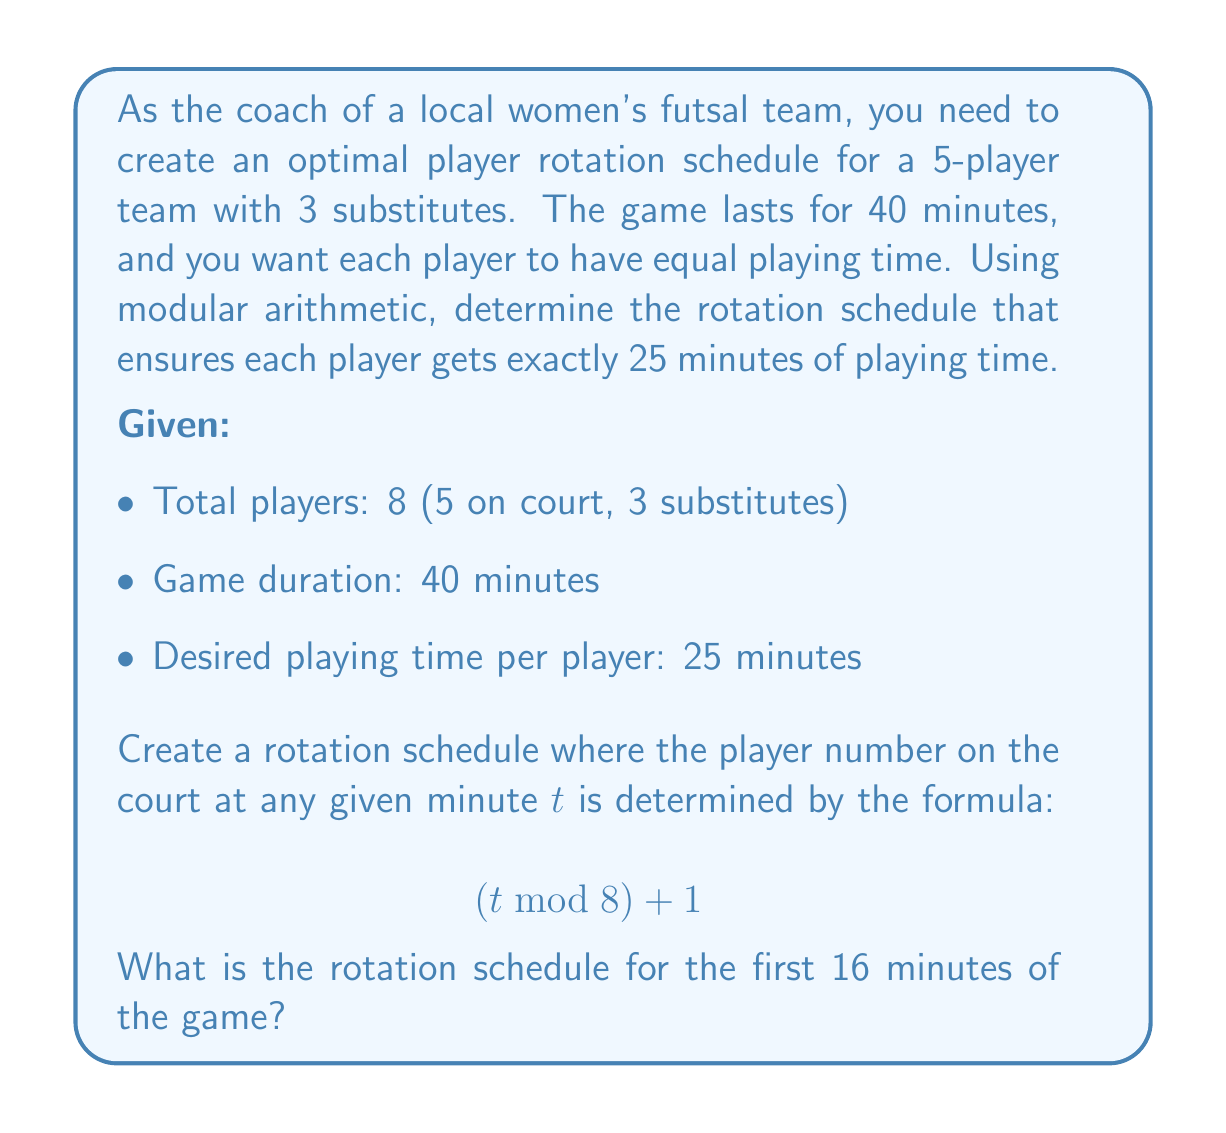Can you solve this math problem? Let's approach this step-by-step:

1) First, we need to understand what the formula means:
   $$(t \bmod 8) + 1$$
   This formula will give us a number between 1 and 8, representing the player number.

2) We'll calculate this for $t = 0$ to $t = 15$ (first 16 minutes):

   For $t = 0$: $(0 \bmod 8) + 1 = 0 + 1 = 1$
   For $t = 1$: $(1 \bmod 8) + 1 = 1 + 1 = 2$
   For $t = 2$: $(2 \bmod 8) + 1 = 2 + 1 = 3$
   For $t = 3$: $(3 \bmod 8) + 1 = 3 + 1 = 4$
   For $t = 4$: $(4 \bmod 8) + 1 = 4 + 1 = 5$
   For $t = 5$: $(5 \bmod 8) + 1 = 5 + 1 = 6$
   For $t = 6$: $(6 \bmod 8) + 1 = 6 + 1 = 7$
   For $t = 7$: $(7 \bmod 8) + 1 = 7 + 1 = 8$
   For $t = 8$: $(8 \bmod 8) + 1 = 0 + 1 = 1$
   For $t = 9$: $(9 \bmod 8) + 1 = 1 + 1 = 2$
   ...and so on.

3) This creates a repeating pattern every 8 minutes.

4) We can represent this as a rotation schedule:

   Minute 0: Players 1, 2, 3, 4, 5 on court
   Minute 1: Players 2, 3, 4, 5, 6 on court
   Minute 2: Players 3, 4, 5, 6, 7 on court
   Minute 3: Players 4, 5, 6, 7, 8 on court
   Minute 4: Players 5, 6, 7, 8, 1 on court
   Minute 5: Players 6, 7, 8, 1, 2 on court
   Minute 6: Players 7, 8, 1, 2, 3 on court
   Minute 7: Players 8, 1, 2, 3, 4 on court
   Minute 8: Players 1, 2, 3, 4, 5 on court (repeats from here)

5) This rotation ensures that each player gets equal playing time. In a 40-minute game, each player will play for 25 minutes (5 cycles of 5 minutes each).
Answer: 1,2,3,4,5; 2,3,4,5,6; 3,4,5,6,7; 4,5,6,7,8; 5,6,7,8,1; 6,7,8,1,2; 7,8,1,2,3; 8,1,2,3,4 